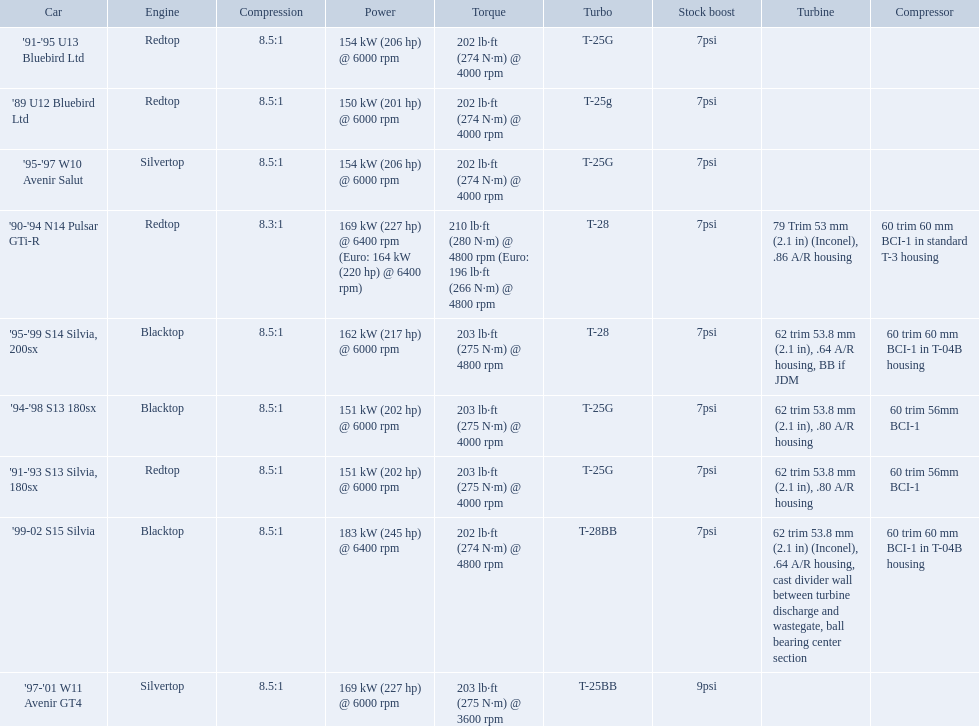What are all of the cars? '89 U12 Bluebird Ltd, '91-'95 U13 Bluebird Ltd, '95-'97 W10 Avenir Salut, '97-'01 W11 Avenir GT4, '90-'94 N14 Pulsar GTi-R, '91-'93 S13 Silvia, 180sx, '94-'98 S13 180sx, '95-'99 S14 Silvia, 200sx, '99-02 S15 Silvia. What is their rated power? 150 kW (201 hp) @ 6000 rpm, 154 kW (206 hp) @ 6000 rpm, 154 kW (206 hp) @ 6000 rpm, 169 kW (227 hp) @ 6000 rpm, 169 kW (227 hp) @ 6400 rpm (Euro: 164 kW (220 hp) @ 6400 rpm), 151 kW (202 hp) @ 6000 rpm, 151 kW (202 hp) @ 6000 rpm, 162 kW (217 hp) @ 6000 rpm, 183 kW (245 hp) @ 6400 rpm. Which car has the most power? '99-02 S15 Silvia. 